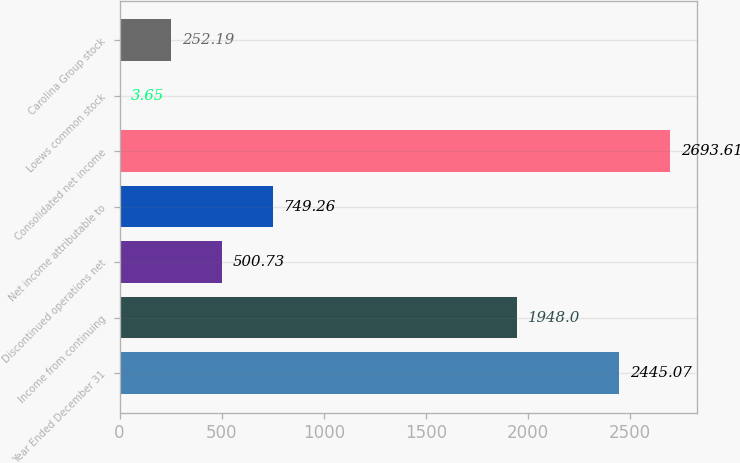<chart> <loc_0><loc_0><loc_500><loc_500><bar_chart><fcel>Year Ended December 31<fcel>Income from continuing<fcel>Discontinued operations net<fcel>Net income attributable to<fcel>Consolidated net income<fcel>Loews common stock<fcel>Carolina Group stock<nl><fcel>2445.07<fcel>1948<fcel>500.73<fcel>749.26<fcel>2693.61<fcel>3.65<fcel>252.19<nl></chart> 